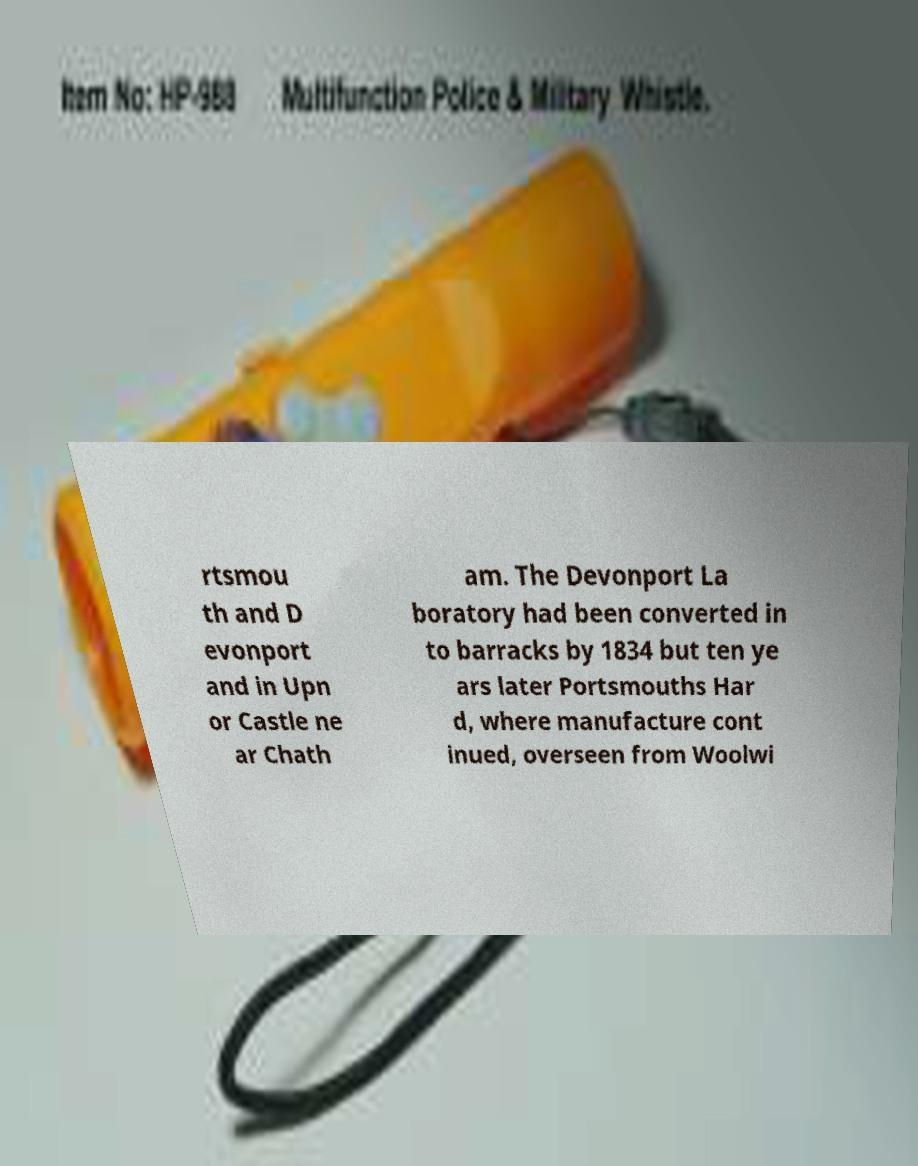For documentation purposes, I need the text within this image transcribed. Could you provide that? rtsmou th and D evonport and in Upn or Castle ne ar Chath am. The Devonport La boratory had been converted in to barracks by 1834 but ten ye ars later Portsmouths Har d, where manufacture cont inued, overseen from Woolwi 